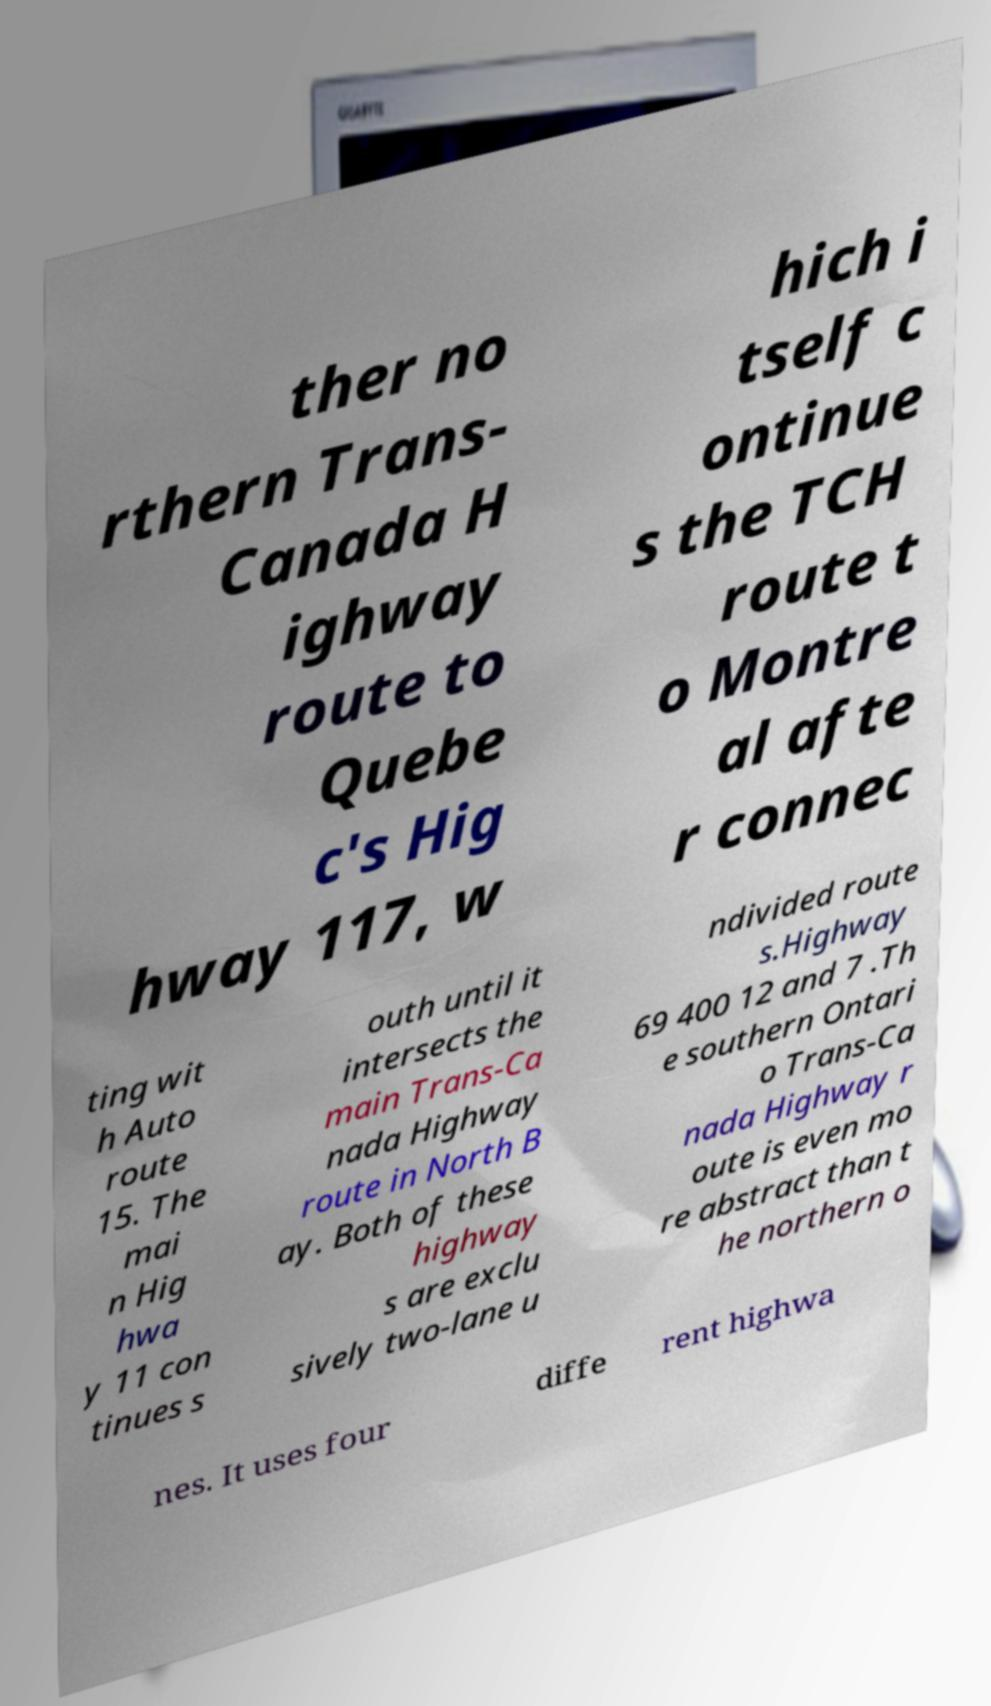Please identify and transcribe the text found in this image. ther no rthern Trans- Canada H ighway route to Quebe c's Hig hway 117, w hich i tself c ontinue s the TCH route t o Montre al afte r connec ting wit h Auto route 15. The mai n Hig hwa y 11 con tinues s outh until it intersects the main Trans-Ca nada Highway route in North B ay. Both of these highway s are exclu sively two-lane u ndivided route s.Highway 69 400 12 and 7 .Th e southern Ontari o Trans-Ca nada Highway r oute is even mo re abstract than t he northern o nes. It uses four diffe rent highwa 